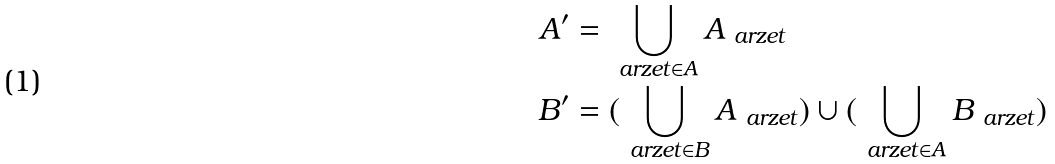<formula> <loc_0><loc_0><loc_500><loc_500>A ^ { \prime } & = \bigcup _ { \ a r z e t \in A } A _ { \ a r z e t } \\ B ^ { \prime } & = ( \bigcup _ { \ a r z e t \in B } A _ { \ a r z e t } ) \cup ( \bigcup _ { \ a r z e t \in A } B _ { \ a r z e t } )</formula> 